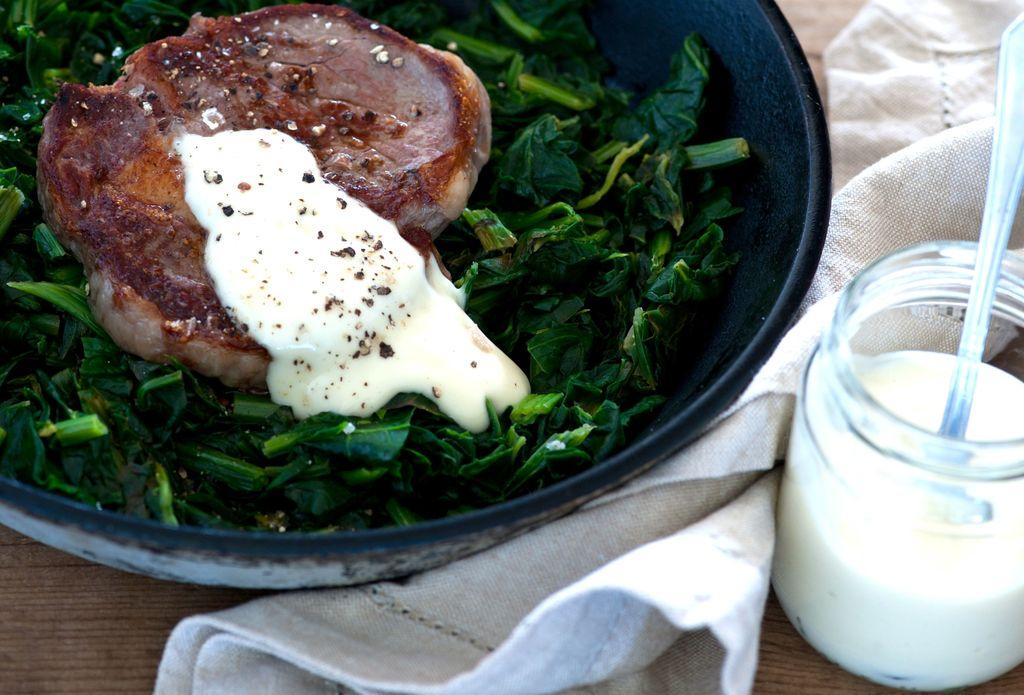What is present in the image that can hold or contain items? There is a bowl and a bottle in the image. What utensil is visible in the image? There is a spoon in the image. What type of material is present in the image that can be used for cleaning or wiping? There is a cloth in the image. What is the primary object on which food is placed in the image? There is a platform in the image on which food is placed. What flavor is the food on the platform in the image? The provided facts do not mention the flavor of the food on the platform in the image. --- Facts: 1. There is a person in the image. 2. The person is wearing a hat. 3. The person is holding a book. 4. The person is standing on a wooden bridge. 5. There is a river flowing beneath the bridge. Absurd Topics: unicorn, rainbow, magic Conversation: Who or what is present in the image? There is a person in the image. What is the person wearing in the image? The person is wearing a hat in the image. What is the person holding in the image? The person is holding a book in the image. What is the person standing on in the image? The person is standing on a wooden bridge in the image. What is visible beneath the bridge in the image? There is a river flowing beneath the bridge in the image. Reasoning: Let's think step by step in order to produce the conversation. We start by identifying the main subject in the image, which is the person. Then, we describe the person's attire, specifically mentioning the hat they are wearing. Next, we focus on the object the person is holding, which is a book. After that, we mention the location where the person is standing, which is a wooden bridge. Finally, we describe the natural setting visible beneath the bridge, which is a river flowing. Absurd Question/Answer: Can you see a unicorn in the image? No, there is no unicorn present in the image. 